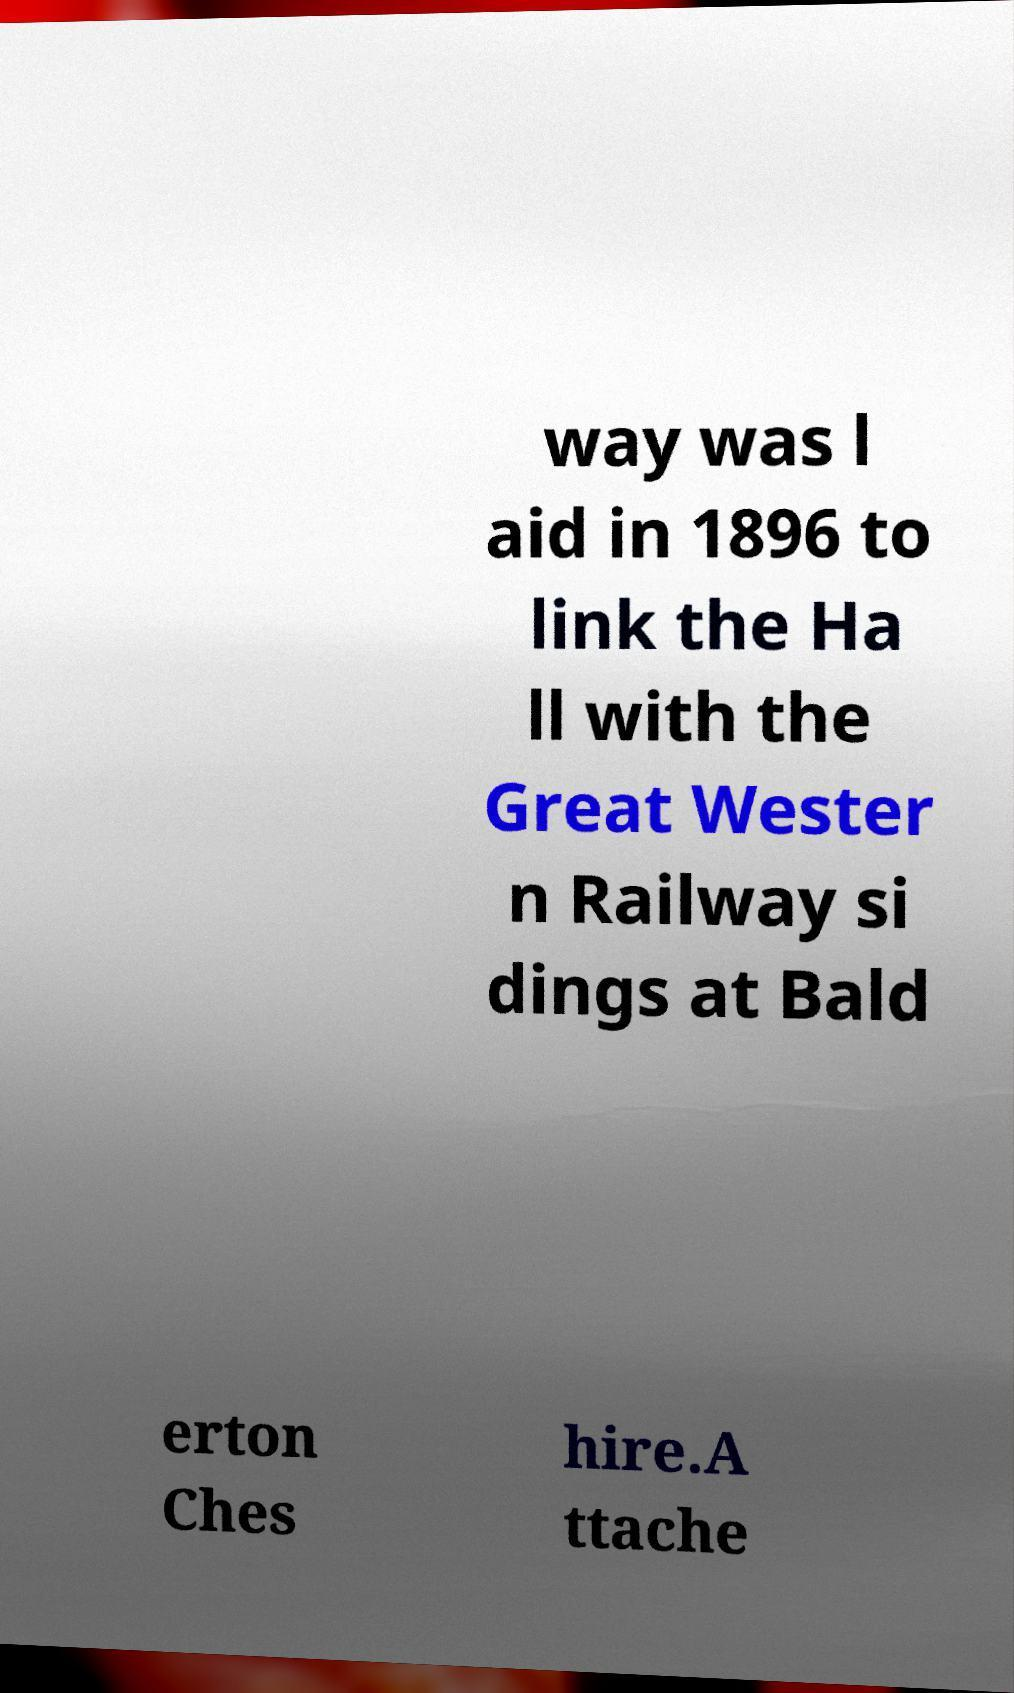Can you read and provide the text displayed in the image?This photo seems to have some interesting text. Can you extract and type it out for me? way was l aid in 1896 to link the Ha ll with the Great Wester n Railway si dings at Bald erton Ches hire.A ttache 